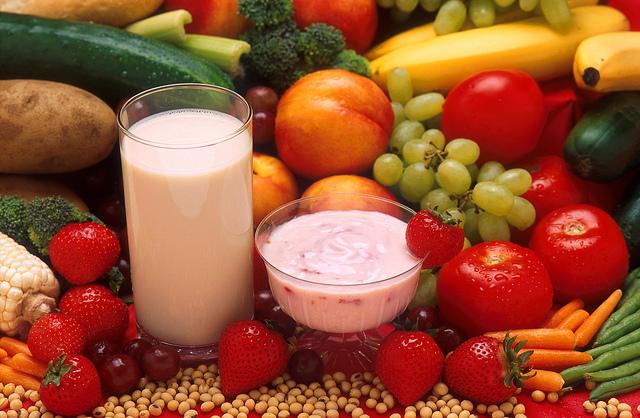Why is the fruit wet?
Answer briefly. Washed. Is there a glass of milk on the table?
Keep it brief. Yes. Is this drink healthy for you?
Write a very short answer. Yes. What fruit is green?
Keep it brief. Grapes. 